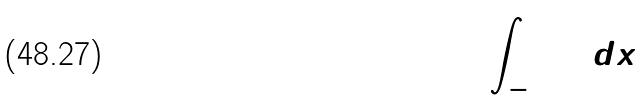Convert formula to latex. <formula><loc_0><loc_0><loc_500><loc_500>\int _ { - 3 } ^ { 0 } ( 3 ) d x</formula> 